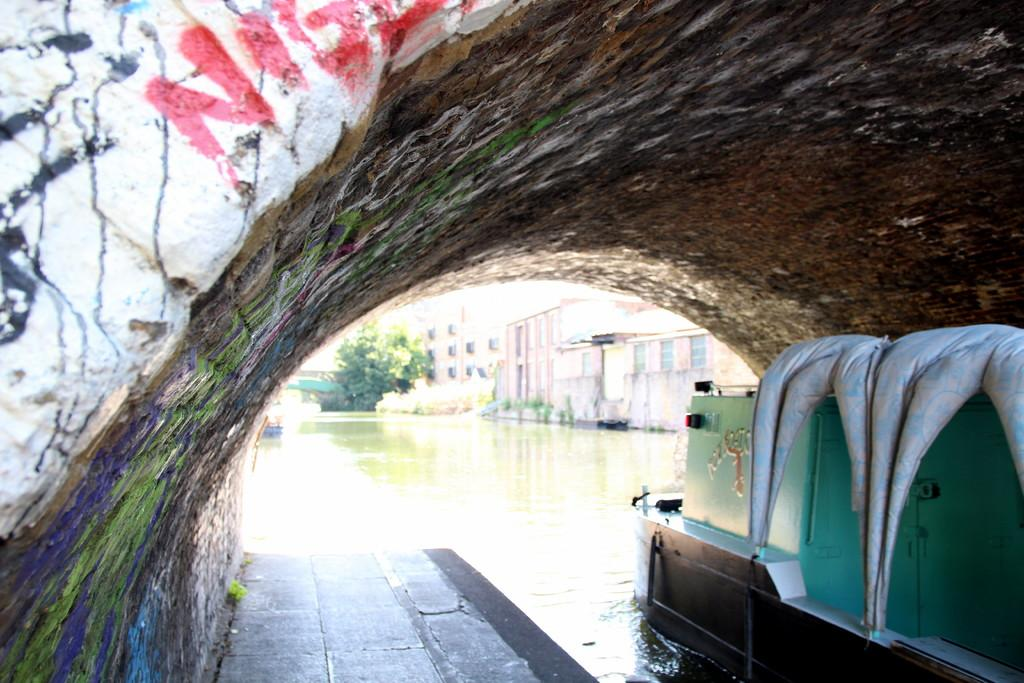What is the main feature in the image? There is a tunnel in the image. What else can be seen in the image besides the tunnel? There is a boat on the water and buildings and trees in the background of the image. What type of fowl can be seen flying through the tunnel in the image? There is no fowl present in the image, and the tunnel is not depicted as having any openings for birds to fly through. 